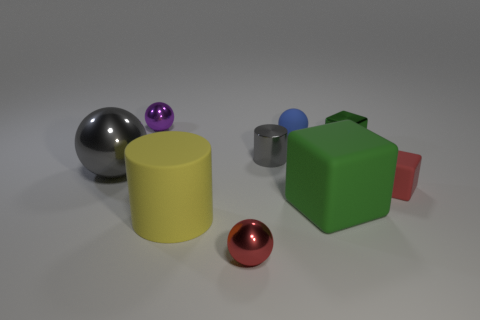Is the number of green rubber blocks on the left side of the purple metal thing the same as the number of yellow shiny objects?
Offer a terse response. Yes. Are there any other things that have the same material as the large yellow object?
Provide a short and direct response. Yes. Do the red thing that is to the left of the green metal cube and the large yellow cylinder have the same material?
Your answer should be very brief. No. Is the number of metallic spheres behind the small blue sphere less than the number of gray metal things?
Keep it short and to the point. Yes. What number of matte things are either purple spheres or big gray balls?
Provide a succinct answer. 0. Do the large metal thing and the small metal cylinder have the same color?
Provide a short and direct response. Yes. Are there any other things that have the same color as the small metal cylinder?
Ensure brevity in your answer.  Yes. There is a green object behind the large metal object; is its shape the same as the tiny matte thing that is in front of the big gray sphere?
Ensure brevity in your answer.  Yes. How many objects are either red spheres or tiny blocks behind the large green matte thing?
Provide a succinct answer. 3. What number of other things are there of the same size as the blue rubber ball?
Provide a succinct answer. 5. 